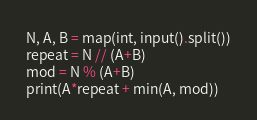<code> <loc_0><loc_0><loc_500><loc_500><_Python_>N, A, B = map(int, input().split())
repeat = N // (A+B)
mod = N % (A+B)
print(A*repeat + min(A, mod))</code> 